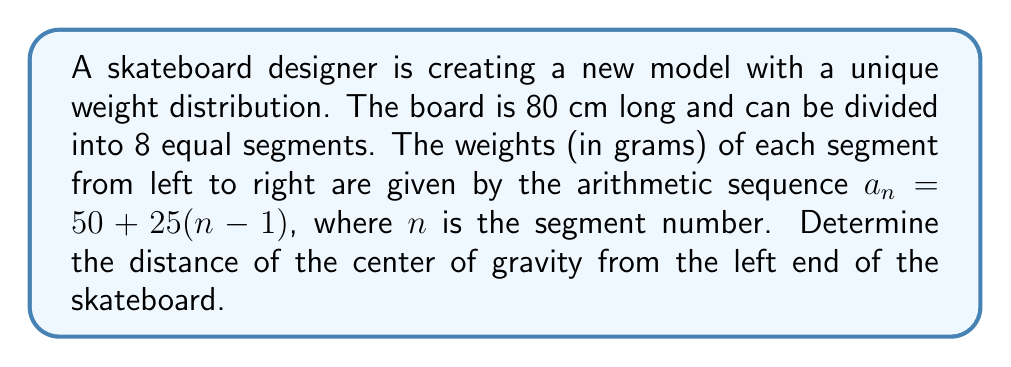Solve this math problem. Let's approach this step-by-step:

1) First, we need to find the weight of each segment:
   $a_1 = 50$ g
   $a_2 = 75$ g
   $a_3 = 100$ g
   $a_4 = 125$ g
   $a_5 = 150$ g
   $a_6 = 175$ g
   $a_7 = 200$ g
   $a_8 = 225$ g

2) The total weight of the skateboard is the sum of these weights:
   $W_{total} = 50 + 75 + 100 + 125 + 150 + 175 + 200 + 225 = 1100$ g

3) Each segment is $80 \div 8 = 10$ cm long. The center of each segment is at:
   5 cm, 15 cm, 25 cm, 35 cm, 45 cm, 55 cm, 65 cm, 75 cm from the left end.

4) To find the center of gravity, we use the formula:
   $$x_{cg} = \frac{\sum_{i=1}^{8} w_i x_i}{\sum_{i=1}^{8} w_i}$$
   where $w_i$ is the weight of each segment and $x_i$ is its distance from the left end.

5) Calculating the numerator:
   $(50 \times 5) + (75 \times 15) + (100 \times 25) + (125 \times 35) + (150 \times 45) + (175 \times 55) + (200 \times 65) + (225 \times 75)$
   $= 250 + 1125 + 2500 + 4375 + 6750 + 9625 + 13000 + 16875$
   $= 54500$ g·cm

6) The denominator is the total weight we calculated earlier: 1100 g

7) Therefore, the center of gravity is at:
   $$x_{cg} = \frac{54500}{1100} = 49.54545...$$

So, the center of gravity is approximately 49.55 cm from the left end of the skateboard.
Answer: 49.55 cm from the left end 